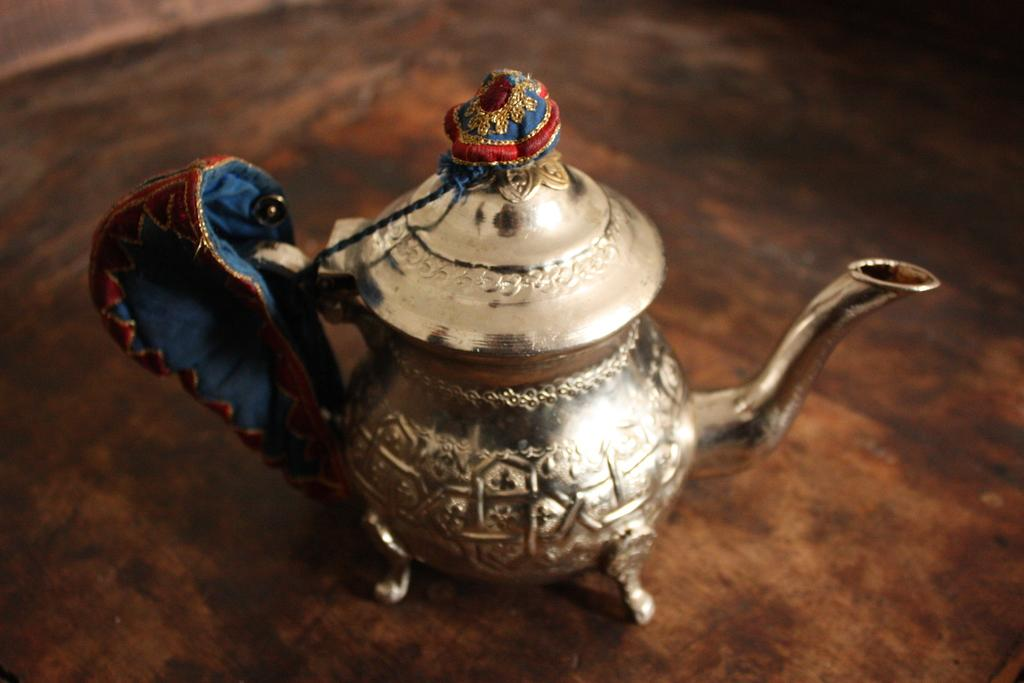What type of material is the object in the image made of? The object in the image is made of metal. What is the object placed on in the image? The metal object is on a wooden surface. How does the metal object contribute to pollution in the image? The image does not provide any information about pollution, and the metal object's presence does not inherently contribute to pollution. 